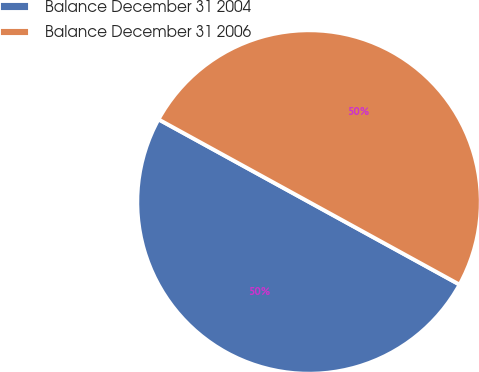Convert chart to OTSL. <chart><loc_0><loc_0><loc_500><loc_500><pie_chart><fcel>Balance December 31 2004<fcel>Balance December 31 2006<nl><fcel>50.0%<fcel>50.0%<nl></chart> 